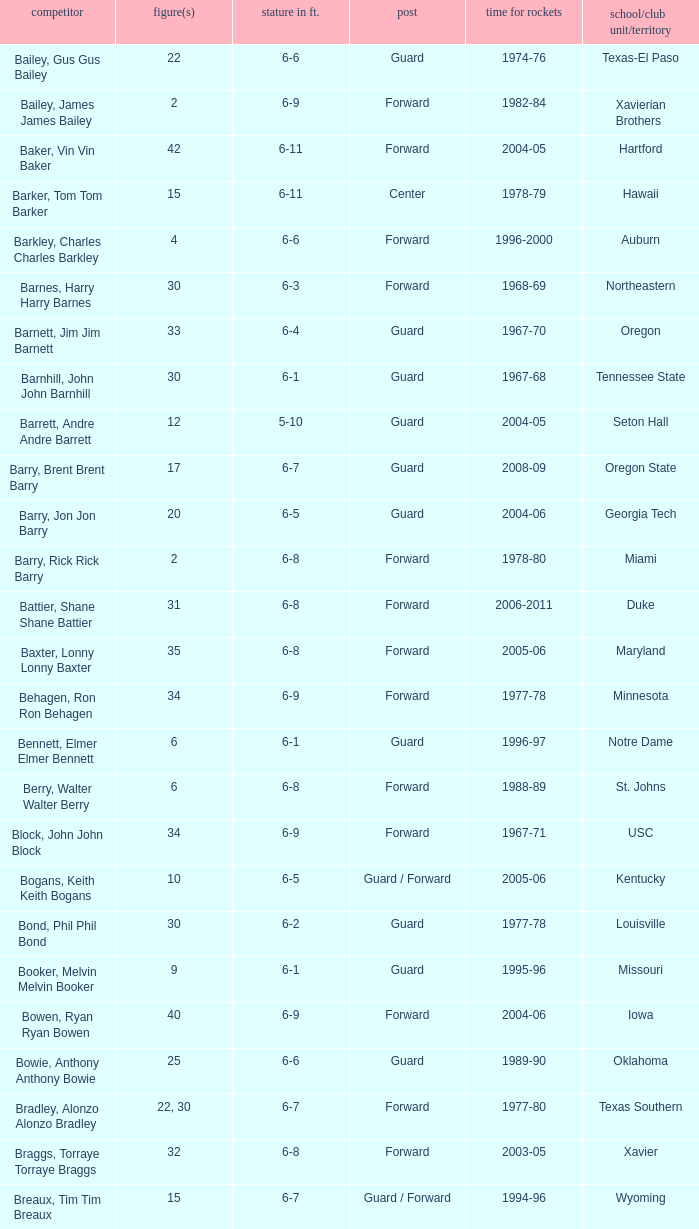What position is number 35 whose height is 6-6? Forward. 